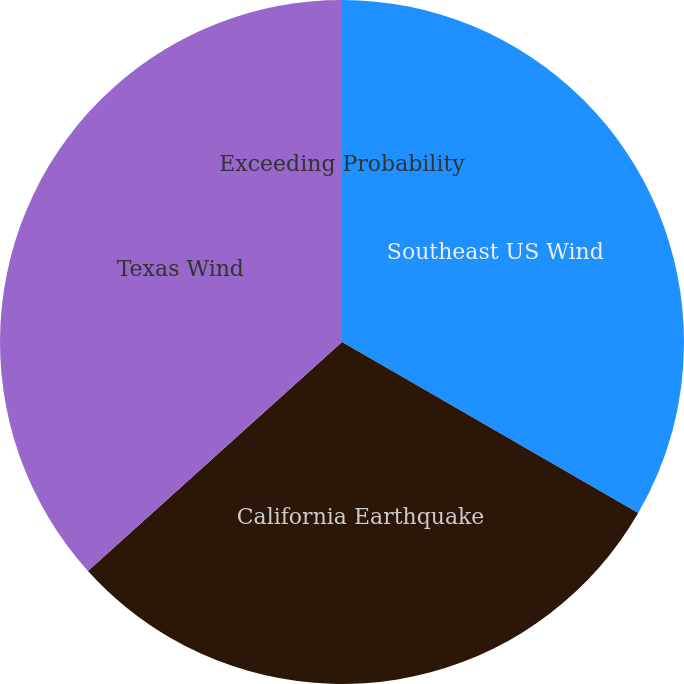<chart> <loc_0><loc_0><loc_500><loc_500><pie_chart><fcel>Exceeding Probability<fcel>Southeast US Wind<fcel>California Earthquake<fcel>Texas Wind<nl><fcel>0.0%<fcel>33.33%<fcel>29.99%<fcel>36.67%<nl></chart> 